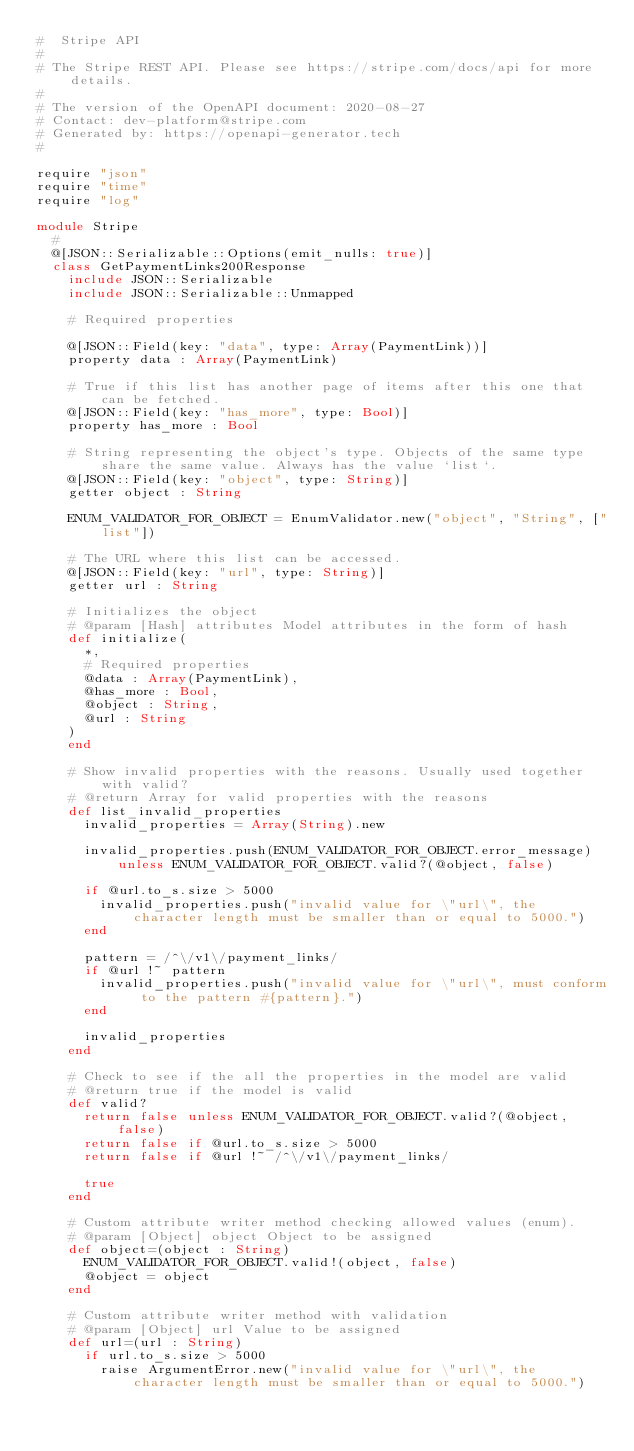<code> <loc_0><loc_0><loc_500><loc_500><_Crystal_>#  Stripe API
#
# The Stripe REST API. Please see https://stripe.com/docs/api for more details.
#
# The version of the OpenAPI document: 2020-08-27
# Contact: dev-platform@stripe.com
# Generated by: https://openapi-generator.tech
#

require "json"
require "time"
require "log"

module Stripe
  #
  @[JSON::Serializable::Options(emit_nulls: true)]
  class GetPaymentLinks200Response
    include JSON::Serializable
    include JSON::Serializable::Unmapped

    # Required properties

    @[JSON::Field(key: "data", type: Array(PaymentLink))]
    property data : Array(PaymentLink)

    # True if this list has another page of items after this one that can be fetched.
    @[JSON::Field(key: "has_more", type: Bool)]
    property has_more : Bool

    # String representing the object's type. Objects of the same type share the same value. Always has the value `list`.
    @[JSON::Field(key: "object", type: String)]
    getter object : String

    ENUM_VALIDATOR_FOR_OBJECT = EnumValidator.new("object", "String", ["list"])

    # The URL where this list can be accessed.
    @[JSON::Field(key: "url", type: String)]
    getter url : String

    # Initializes the object
    # @param [Hash] attributes Model attributes in the form of hash
    def initialize(
      *,
      # Required properties
      @data : Array(PaymentLink),
      @has_more : Bool,
      @object : String,
      @url : String
    )
    end

    # Show invalid properties with the reasons. Usually used together with valid?
    # @return Array for valid properties with the reasons
    def list_invalid_properties
      invalid_properties = Array(String).new

      invalid_properties.push(ENUM_VALIDATOR_FOR_OBJECT.error_message) unless ENUM_VALIDATOR_FOR_OBJECT.valid?(@object, false)

      if @url.to_s.size > 5000
        invalid_properties.push("invalid value for \"url\", the character length must be smaller than or equal to 5000.")
      end

      pattern = /^\/v1\/payment_links/
      if @url !~ pattern
        invalid_properties.push("invalid value for \"url\", must conform to the pattern #{pattern}.")
      end

      invalid_properties
    end

    # Check to see if the all the properties in the model are valid
    # @return true if the model is valid
    def valid?
      return false unless ENUM_VALIDATOR_FOR_OBJECT.valid?(@object, false)
      return false if @url.to_s.size > 5000
      return false if @url !~ /^\/v1\/payment_links/

      true
    end

    # Custom attribute writer method checking allowed values (enum).
    # @param [Object] object Object to be assigned
    def object=(object : String)
      ENUM_VALIDATOR_FOR_OBJECT.valid!(object, false)
      @object = object
    end

    # Custom attribute writer method with validation
    # @param [Object] url Value to be assigned
    def url=(url : String)
      if url.to_s.size > 5000
        raise ArgumentError.new("invalid value for \"url\", the character length must be smaller than or equal to 5000.")</code> 